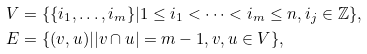Convert formula to latex. <formula><loc_0><loc_0><loc_500><loc_500>V & = \{ \{ i _ { 1 } , \dots , i _ { m } \} | 1 \leq i _ { 1 } < \cdots < i _ { m } \leq n , i _ { j } \in \mathbb { Z } \} , \\ E & = \{ ( v , u ) | | v \cap u | = m - 1 , v , u \in V \} ,</formula> 